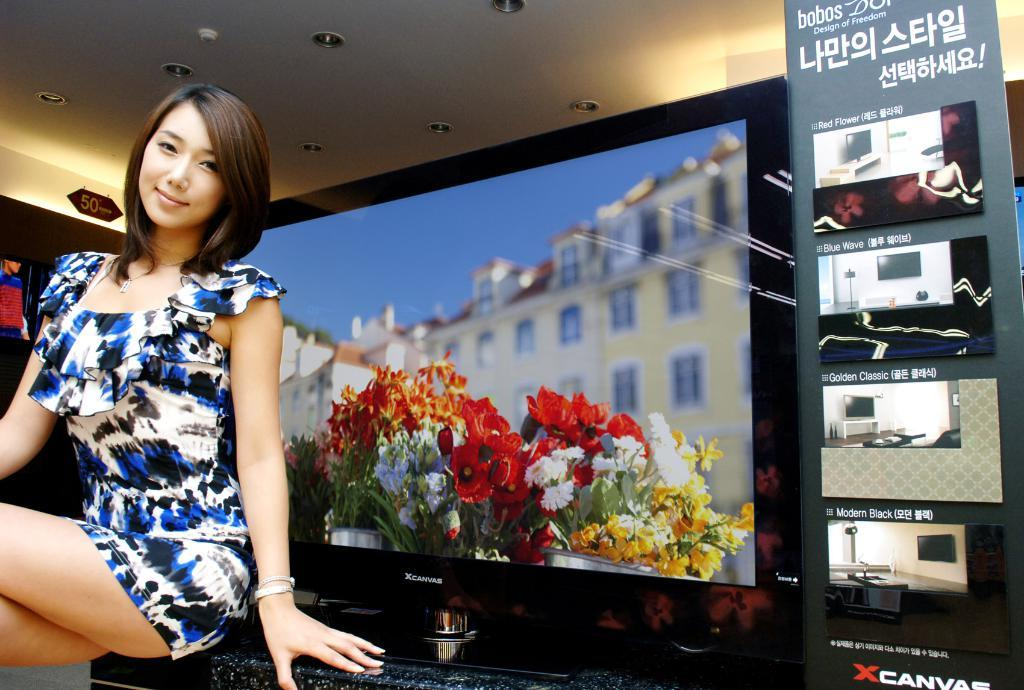<image>
Present a compact description of the photo's key features. A woman sitting in front of an XCanvas brand tv. 